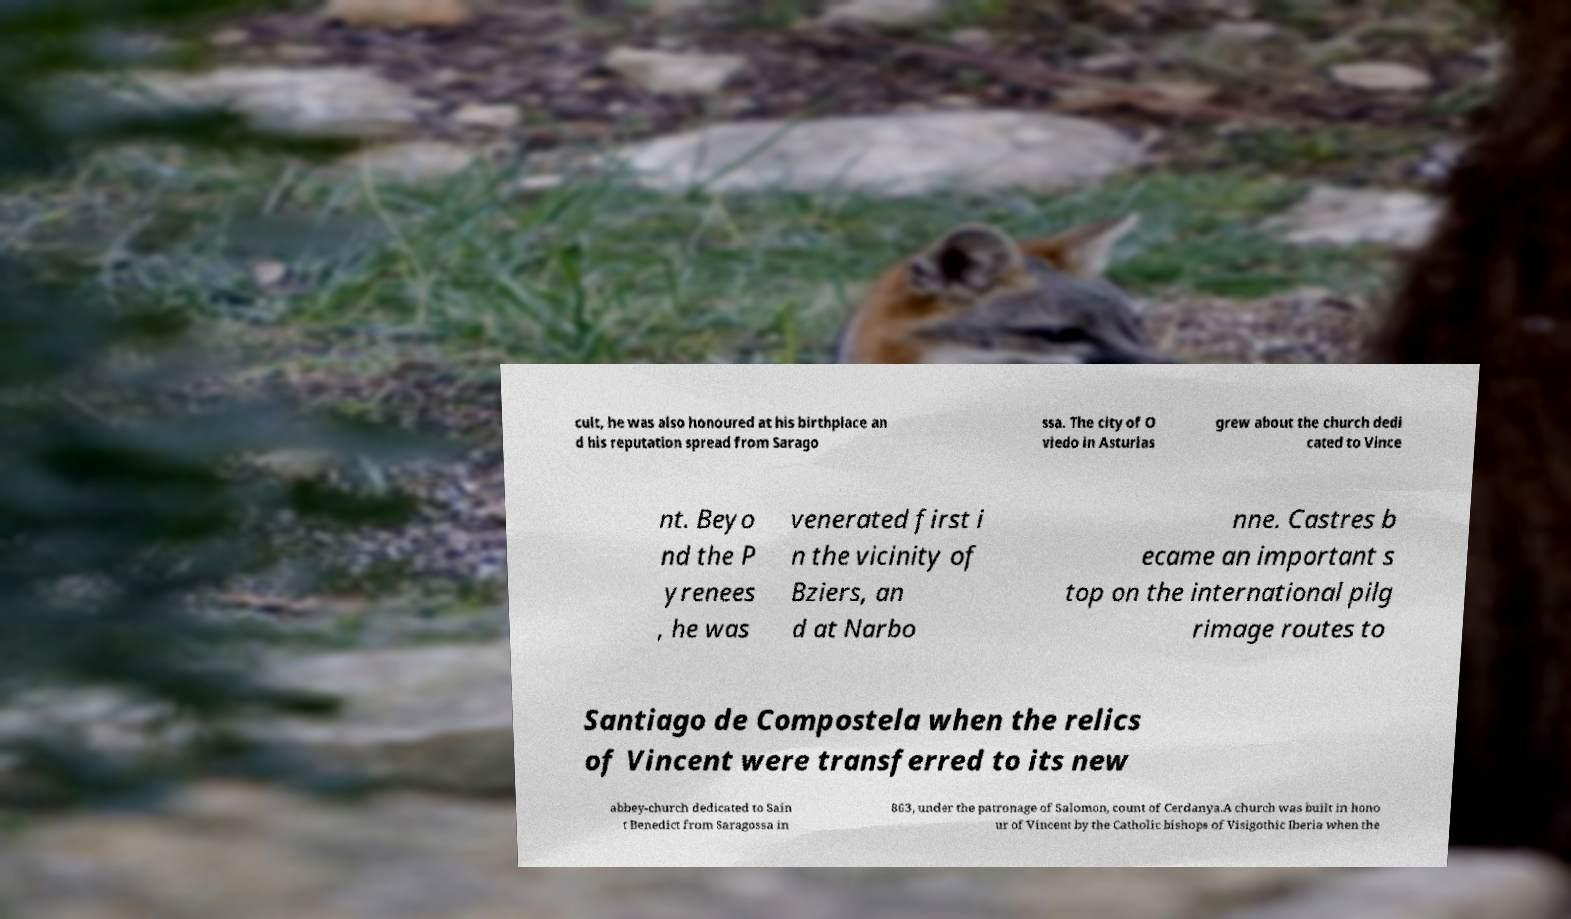There's text embedded in this image that I need extracted. Can you transcribe it verbatim? cult, he was also honoured at his birthplace an d his reputation spread from Sarago ssa. The city of O viedo in Asturias grew about the church dedi cated to Vince nt. Beyo nd the P yrenees , he was venerated first i n the vicinity of Bziers, an d at Narbo nne. Castres b ecame an important s top on the international pilg rimage routes to Santiago de Compostela when the relics of Vincent were transferred to its new abbey-church dedicated to Sain t Benedict from Saragossa in 863, under the patronage of Salomon, count of Cerdanya.A church was built in hono ur of Vincent by the Catholic bishops of Visigothic Iberia when the 